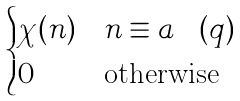<formula> <loc_0><loc_0><loc_500><loc_500>\begin{cases} \chi ( n ) & n \equiv a \pod { q } \\ 0 & \text {otherwise} \end{cases}</formula> 